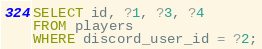<code> <loc_0><loc_0><loc_500><loc_500><_SQL_>SELECT id, ?1, ?3, ?4
FROM players
WHERE discord_user_id = ?2;
</code> 